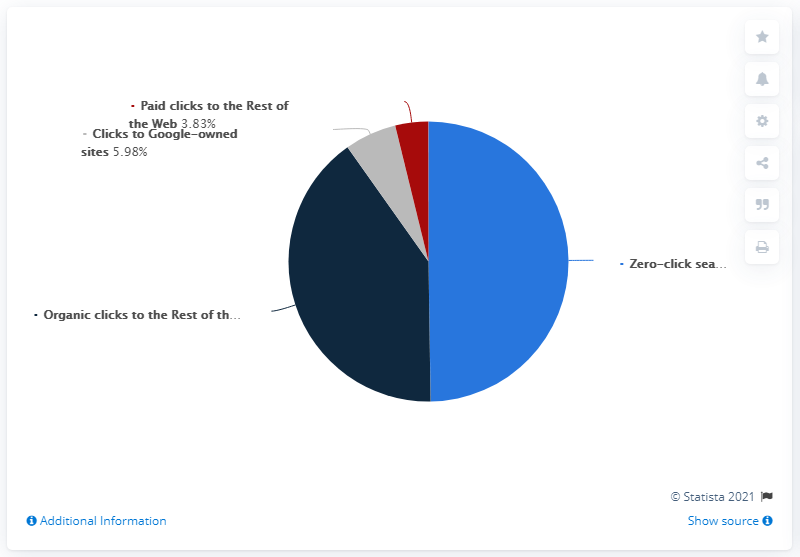Highlight a few significant elements in this photo. Zero-click searches make up half of the pie chart. The least two numbers in a sequence are 2.15... and 2.16... respectively, and they differ by 0.01 units. Approximately 40.42% of clicks on organic post-search results came from non-Google sites. In a study of U.S. Google Search users, it was found that 49.76% were able to resolve their queries without needing to click further. 